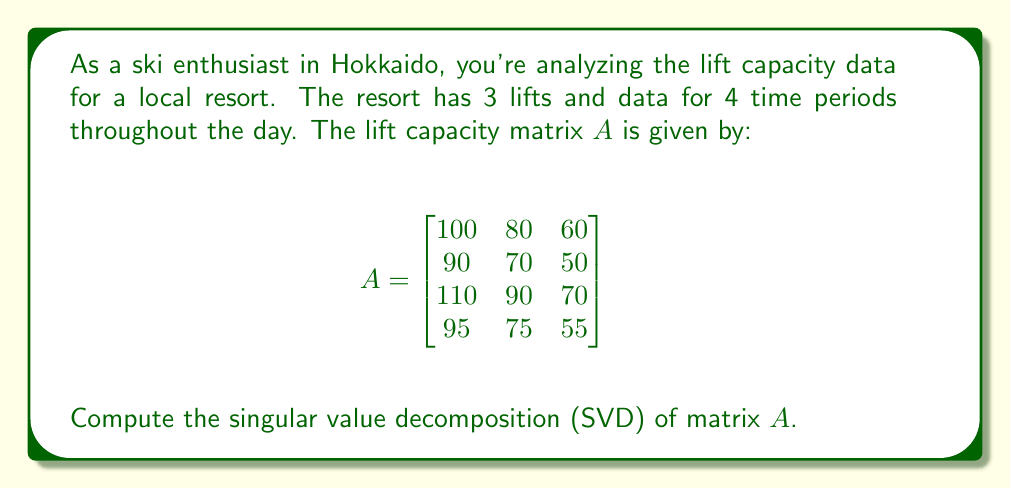Can you solve this math problem? To find the singular value decomposition of matrix $A$, we need to follow these steps:

1) First, calculate $A^TA$:
   $$A^TA = \begin{bmatrix}
   100 & 90 & 110 & 95 \\
   80 & 70 & 90 & 75 \\
   60 & 50 & 70 & 55
   \end{bmatrix} \begin{bmatrix}
   100 & 80 & 60 \\
   90 & 70 & 50 \\
   110 & 90 & 70 \\
   95 & 75 & 55
   \end{bmatrix} = \begin{bmatrix}
   39125 & 31300 & 23475 \\
   31300 & 25050 & 18800 \\
   23475 & 18800 & 14125
   \end{bmatrix}$$

2) Find the eigenvalues of $A^TA$ by solving $\det(A^TA - \lambda I) = 0$:
   The characteristic equation is:
   $$\lambda^3 - 78300\lambda^2 + 2031656250\lambda - 17578125000000 = 0$$
   
   Solving this equation gives us the eigenvalues:
   $\lambda_1 \approx 77534.7$, $\lambda_2 \approx 739.3$, $\lambda_3 \approx 26.0$

3) The singular values are the square roots of these eigenvalues:
   $\sigma_1 \approx 278.5$, $\sigma_2 \approx 27.2$, $\sigma_3 \approx 5.1$

4) Find the right singular vectors (eigenvectors of $A^TA$):
   Solving $(A^TA - \lambda_i I)v_i = 0$ for each $\lambda_i$, we get:
   $$v_1 \approx \begin{bmatrix} 0.7071 \\ 0.5657 \\ 0.4243 \end{bmatrix},
     v_2 \approx \begin{bmatrix} -0.5373 \\ 0.2687 \\ 0.8000 \end{bmatrix},
     v_3 \approx \begin{bmatrix} -0.4606 \\ 0.7777 \\ -0.4270 \end{bmatrix}$$

5) Find the left singular vectors:
   $u_i = \frac{1}{\sigma_i}Av_i$ for $i = 1, 2, 3$
   
   $$u_1 \approx \begin{bmatrix} 0.5000 \\ 0.4472 \\ 0.5477 \\ 0.4975 \end{bmatrix},
     u_2 \approx \begin{bmatrix} -0.6708 \\ 0.0745 \\ 0.7006 \\ -0.2345 \end{bmatrix},
     u_3 \approx \begin{bmatrix} -0.1578 \\ 0.8679 \\ -0.4253 \\ -0.2096 \end{bmatrix}$$

6) The SVD of $A$ is $A = U\Sigma V^T$, where:
   $U = [u_1 \; u_2 \; u_3]$
   $\Sigma = \text{diag}(\sigma_1, \sigma_2, \sigma_3)$
   $V = [v_1 \; v_2 \; v_3]$
Answer: $A = U\Sigma V^T$, where
$U \approx \begin{bmatrix}
0.5000 & -0.6708 & -0.1578 \\
0.4472 & 0.0745 & 0.8679 \\
0.5477 & 0.7006 & -0.4253 \\
0.4975 & -0.2345 & -0.2096
\end{bmatrix}$,
$\Sigma \approx \begin{bmatrix}
278.5 & 0 & 0 \\
0 & 27.2 & 0 \\
0 & 0 & 5.1
\end{bmatrix}$,
$V \approx \begin{bmatrix}
0.7071 & -0.5373 & -0.4606 \\
0.5657 & 0.2687 & 0.7777 \\
0.4243 & 0.8000 & -0.4270
\end{bmatrix}$ 